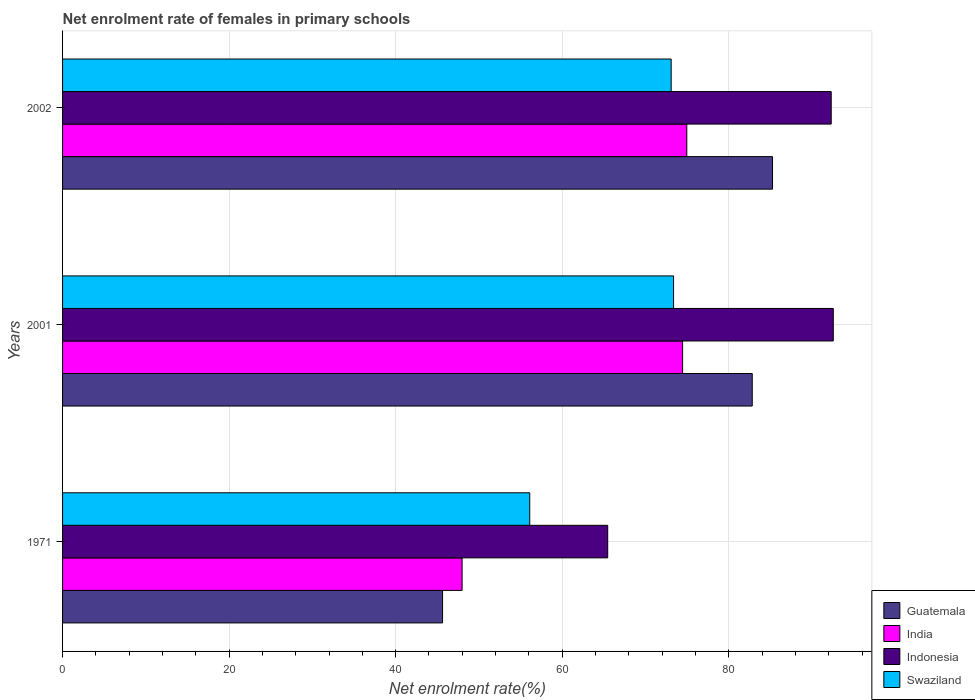How many groups of bars are there?
Make the answer very short. 3. How many bars are there on the 3rd tick from the top?
Ensure brevity in your answer.  4. What is the net enrolment rate of females in primary schools in Guatemala in 2001?
Your answer should be very brief. 82.82. Across all years, what is the maximum net enrolment rate of females in primary schools in Guatemala?
Keep it short and to the point. 85.26. Across all years, what is the minimum net enrolment rate of females in primary schools in Indonesia?
Your response must be concise. 65.46. In which year was the net enrolment rate of females in primary schools in Indonesia maximum?
Provide a short and direct response. 2001. In which year was the net enrolment rate of females in primary schools in Swaziland minimum?
Your answer should be compact. 1971. What is the total net enrolment rate of females in primary schools in Indonesia in the graph?
Give a very brief answer. 250.32. What is the difference between the net enrolment rate of females in primary schools in Indonesia in 1971 and that in 2002?
Make the answer very short. -26.84. What is the difference between the net enrolment rate of females in primary schools in Indonesia in 1971 and the net enrolment rate of females in primary schools in India in 2001?
Your answer should be very brief. -8.99. What is the average net enrolment rate of females in primary schools in India per year?
Make the answer very short. 65.8. In the year 2002, what is the difference between the net enrolment rate of females in primary schools in Guatemala and net enrolment rate of females in primary schools in Swaziland?
Provide a succinct answer. 12.17. In how many years, is the net enrolment rate of females in primary schools in Swaziland greater than 12 %?
Give a very brief answer. 3. What is the ratio of the net enrolment rate of females in primary schools in Indonesia in 2001 to that in 2002?
Keep it short and to the point. 1. Is the net enrolment rate of females in primary schools in Swaziland in 1971 less than that in 2001?
Keep it short and to the point. Yes. Is the difference between the net enrolment rate of females in primary schools in Guatemala in 1971 and 2001 greater than the difference between the net enrolment rate of females in primary schools in Swaziland in 1971 and 2001?
Your answer should be very brief. No. What is the difference between the highest and the second highest net enrolment rate of females in primary schools in Swaziland?
Give a very brief answer. 0.29. What is the difference between the highest and the lowest net enrolment rate of females in primary schools in Swaziland?
Make the answer very short. 17.27. In how many years, is the net enrolment rate of females in primary schools in Swaziland greater than the average net enrolment rate of females in primary schools in Swaziland taken over all years?
Provide a succinct answer. 2. Is the sum of the net enrolment rate of females in primary schools in Indonesia in 1971 and 2002 greater than the maximum net enrolment rate of females in primary schools in Guatemala across all years?
Keep it short and to the point. Yes. Is it the case that in every year, the sum of the net enrolment rate of females in primary schools in Guatemala and net enrolment rate of females in primary schools in India is greater than the sum of net enrolment rate of females in primary schools in Swaziland and net enrolment rate of females in primary schools in Indonesia?
Keep it short and to the point. No. What does the 4th bar from the bottom in 1971 represents?
Keep it short and to the point. Swaziland. How many bars are there?
Offer a terse response. 12. How many years are there in the graph?
Your answer should be compact. 3. Are the values on the major ticks of X-axis written in scientific E-notation?
Give a very brief answer. No. Where does the legend appear in the graph?
Give a very brief answer. Bottom right. How many legend labels are there?
Ensure brevity in your answer.  4. What is the title of the graph?
Your answer should be compact. Net enrolment rate of females in primary schools. Does "Australia" appear as one of the legend labels in the graph?
Offer a very short reply. No. What is the label or title of the X-axis?
Provide a succinct answer. Net enrolment rate(%). What is the Net enrolment rate(%) of Guatemala in 1971?
Keep it short and to the point. 45.63. What is the Net enrolment rate(%) in India in 1971?
Offer a terse response. 47.98. What is the Net enrolment rate(%) in Indonesia in 1971?
Your response must be concise. 65.46. What is the Net enrolment rate(%) in Swaziland in 1971?
Provide a succinct answer. 56.1. What is the Net enrolment rate(%) of Guatemala in 2001?
Make the answer very short. 82.82. What is the Net enrolment rate(%) of India in 2001?
Ensure brevity in your answer.  74.46. What is the Net enrolment rate(%) of Indonesia in 2001?
Offer a very short reply. 92.55. What is the Net enrolment rate(%) of Swaziland in 2001?
Your answer should be very brief. 73.37. What is the Net enrolment rate(%) in Guatemala in 2002?
Your answer should be very brief. 85.26. What is the Net enrolment rate(%) of India in 2002?
Provide a short and direct response. 74.96. What is the Net enrolment rate(%) in Indonesia in 2002?
Ensure brevity in your answer.  92.3. What is the Net enrolment rate(%) of Swaziland in 2002?
Your answer should be compact. 73.08. Across all years, what is the maximum Net enrolment rate(%) of Guatemala?
Keep it short and to the point. 85.26. Across all years, what is the maximum Net enrolment rate(%) of India?
Provide a succinct answer. 74.96. Across all years, what is the maximum Net enrolment rate(%) in Indonesia?
Give a very brief answer. 92.55. Across all years, what is the maximum Net enrolment rate(%) in Swaziland?
Ensure brevity in your answer.  73.37. Across all years, what is the minimum Net enrolment rate(%) in Guatemala?
Your answer should be compact. 45.63. Across all years, what is the minimum Net enrolment rate(%) in India?
Your answer should be compact. 47.98. Across all years, what is the minimum Net enrolment rate(%) of Indonesia?
Offer a very short reply. 65.46. Across all years, what is the minimum Net enrolment rate(%) of Swaziland?
Offer a very short reply. 56.1. What is the total Net enrolment rate(%) in Guatemala in the graph?
Give a very brief answer. 213.71. What is the total Net enrolment rate(%) of India in the graph?
Make the answer very short. 197.4. What is the total Net enrolment rate(%) in Indonesia in the graph?
Your answer should be compact. 250.32. What is the total Net enrolment rate(%) of Swaziland in the graph?
Provide a short and direct response. 202.56. What is the difference between the Net enrolment rate(%) of Guatemala in 1971 and that in 2001?
Your answer should be very brief. -37.19. What is the difference between the Net enrolment rate(%) of India in 1971 and that in 2001?
Ensure brevity in your answer.  -26.48. What is the difference between the Net enrolment rate(%) in Indonesia in 1971 and that in 2001?
Offer a terse response. -27.09. What is the difference between the Net enrolment rate(%) of Swaziland in 1971 and that in 2001?
Provide a succinct answer. -17.27. What is the difference between the Net enrolment rate(%) of Guatemala in 1971 and that in 2002?
Make the answer very short. -39.62. What is the difference between the Net enrolment rate(%) of India in 1971 and that in 2002?
Provide a succinct answer. -26.98. What is the difference between the Net enrolment rate(%) of Indonesia in 1971 and that in 2002?
Make the answer very short. -26.84. What is the difference between the Net enrolment rate(%) of Swaziland in 1971 and that in 2002?
Make the answer very short. -16.98. What is the difference between the Net enrolment rate(%) in Guatemala in 2001 and that in 2002?
Offer a very short reply. -2.43. What is the difference between the Net enrolment rate(%) in India in 2001 and that in 2002?
Your answer should be compact. -0.5. What is the difference between the Net enrolment rate(%) in Indonesia in 2001 and that in 2002?
Your answer should be compact. 0.25. What is the difference between the Net enrolment rate(%) of Swaziland in 2001 and that in 2002?
Offer a very short reply. 0.29. What is the difference between the Net enrolment rate(%) in Guatemala in 1971 and the Net enrolment rate(%) in India in 2001?
Offer a very short reply. -28.83. What is the difference between the Net enrolment rate(%) in Guatemala in 1971 and the Net enrolment rate(%) in Indonesia in 2001?
Ensure brevity in your answer.  -46.92. What is the difference between the Net enrolment rate(%) in Guatemala in 1971 and the Net enrolment rate(%) in Swaziland in 2001?
Keep it short and to the point. -27.74. What is the difference between the Net enrolment rate(%) in India in 1971 and the Net enrolment rate(%) in Indonesia in 2001?
Provide a short and direct response. -44.58. What is the difference between the Net enrolment rate(%) in India in 1971 and the Net enrolment rate(%) in Swaziland in 2001?
Make the answer very short. -25.4. What is the difference between the Net enrolment rate(%) of Indonesia in 1971 and the Net enrolment rate(%) of Swaziland in 2001?
Your answer should be very brief. -7.91. What is the difference between the Net enrolment rate(%) in Guatemala in 1971 and the Net enrolment rate(%) in India in 2002?
Keep it short and to the point. -29.33. What is the difference between the Net enrolment rate(%) in Guatemala in 1971 and the Net enrolment rate(%) in Indonesia in 2002?
Provide a short and direct response. -46.67. What is the difference between the Net enrolment rate(%) in Guatemala in 1971 and the Net enrolment rate(%) in Swaziland in 2002?
Provide a short and direct response. -27.45. What is the difference between the Net enrolment rate(%) in India in 1971 and the Net enrolment rate(%) in Indonesia in 2002?
Your response must be concise. -44.32. What is the difference between the Net enrolment rate(%) in India in 1971 and the Net enrolment rate(%) in Swaziland in 2002?
Your answer should be very brief. -25.11. What is the difference between the Net enrolment rate(%) of Indonesia in 1971 and the Net enrolment rate(%) of Swaziland in 2002?
Ensure brevity in your answer.  -7.62. What is the difference between the Net enrolment rate(%) of Guatemala in 2001 and the Net enrolment rate(%) of India in 2002?
Your response must be concise. 7.86. What is the difference between the Net enrolment rate(%) of Guatemala in 2001 and the Net enrolment rate(%) of Indonesia in 2002?
Offer a very short reply. -9.48. What is the difference between the Net enrolment rate(%) in Guatemala in 2001 and the Net enrolment rate(%) in Swaziland in 2002?
Give a very brief answer. 9.74. What is the difference between the Net enrolment rate(%) in India in 2001 and the Net enrolment rate(%) in Indonesia in 2002?
Offer a very short reply. -17.84. What is the difference between the Net enrolment rate(%) in India in 2001 and the Net enrolment rate(%) in Swaziland in 2002?
Your answer should be very brief. 1.37. What is the difference between the Net enrolment rate(%) in Indonesia in 2001 and the Net enrolment rate(%) in Swaziland in 2002?
Offer a terse response. 19.47. What is the average Net enrolment rate(%) of Guatemala per year?
Keep it short and to the point. 71.24. What is the average Net enrolment rate(%) of India per year?
Provide a succinct answer. 65.8. What is the average Net enrolment rate(%) in Indonesia per year?
Provide a succinct answer. 83.44. What is the average Net enrolment rate(%) of Swaziland per year?
Your answer should be very brief. 67.52. In the year 1971, what is the difference between the Net enrolment rate(%) in Guatemala and Net enrolment rate(%) in India?
Give a very brief answer. -2.35. In the year 1971, what is the difference between the Net enrolment rate(%) in Guatemala and Net enrolment rate(%) in Indonesia?
Your answer should be compact. -19.83. In the year 1971, what is the difference between the Net enrolment rate(%) of Guatemala and Net enrolment rate(%) of Swaziland?
Make the answer very short. -10.47. In the year 1971, what is the difference between the Net enrolment rate(%) in India and Net enrolment rate(%) in Indonesia?
Offer a terse response. -17.49. In the year 1971, what is the difference between the Net enrolment rate(%) of India and Net enrolment rate(%) of Swaziland?
Keep it short and to the point. -8.12. In the year 1971, what is the difference between the Net enrolment rate(%) in Indonesia and Net enrolment rate(%) in Swaziland?
Give a very brief answer. 9.36. In the year 2001, what is the difference between the Net enrolment rate(%) in Guatemala and Net enrolment rate(%) in India?
Ensure brevity in your answer.  8.36. In the year 2001, what is the difference between the Net enrolment rate(%) of Guatemala and Net enrolment rate(%) of Indonesia?
Provide a succinct answer. -9.73. In the year 2001, what is the difference between the Net enrolment rate(%) in Guatemala and Net enrolment rate(%) in Swaziland?
Your answer should be very brief. 9.45. In the year 2001, what is the difference between the Net enrolment rate(%) in India and Net enrolment rate(%) in Indonesia?
Offer a terse response. -18.1. In the year 2001, what is the difference between the Net enrolment rate(%) of India and Net enrolment rate(%) of Swaziland?
Make the answer very short. 1.08. In the year 2001, what is the difference between the Net enrolment rate(%) in Indonesia and Net enrolment rate(%) in Swaziland?
Give a very brief answer. 19.18. In the year 2002, what is the difference between the Net enrolment rate(%) of Guatemala and Net enrolment rate(%) of India?
Your response must be concise. 10.29. In the year 2002, what is the difference between the Net enrolment rate(%) in Guatemala and Net enrolment rate(%) in Indonesia?
Your answer should be compact. -7.05. In the year 2002, what is the difference between the Net enrolment rate(%) in Guatemala and Net enrolment rate(%) in Swaziland?
Make the answer very short. 12.17. In the year 2002, what is the difference between the Net enrolment rate(%) in India and Net enrolment rate(%) in Indonesia?
Provide a short and direct response. -17.34. In the year 2002, what is the difference between the Net enrolment rate(%) in India and Net enrolment rate(%) in Swaziland?
Your answer should be compact. 1.88. In the year 2002, what is the difference between the Net enrolment rate(%) in Indonesia and Net enrolment rate(%) in Swaziland?
Ensure brevity in your answer.  19.22. What is the ratio of the Net enrolment rate(%) in Guatemala in 1971 to that in 2001?
Your answer should be compact. 0.55. What is the ratio of the Net enrolment rate(%) in India in 1971 to that in 2001?
Give a very brief answer. 0.64. What is the ratio of the Net enrolment rate(%) of Indonesia in 1971 to that in 2001?
Keep it short and to the point. 0.71. What is the ratio of the Net enrolment rate(%) of Swaziland in 1971 to that in 2001?
Your answer should be compact. 0.76. What is the ratio of the Net enrolment rate(%) of Guatemala in 1971 to that in 2002?
Provide a short and direct response. 0.54. What is the ratio of the Net enrolment rate(%) in India in 1971 to that in 2002?
Make the answer very short. 0.64. What is the ratio of the Net enrolment rate(%) in Indonesia in 1971 to that in 2002?
Keep it short and to the point. 0.71. What is the ratio of the Net enrolment rate(%) of Swaziland in 1971 to that in 2002?
Ensure brevity in your answer.  0.77. What is the ratio of the Net enrolment rate(%) of Guatemala in 2001 to that in 2002?
Your answer should be very brief. 0.97. What is the ratio of the Net enrolment rate(%) in Indonesia in 2001 to that in 2002?
Provide a succinct answer. 1. What is the difference between the highest and the second highest Net enrolment rate(%) in Guatemala?
Give a very brief answer. 2.43. What is the difference between the highest and the second highest Net enrolment rate(%) of India?
Your response must be concise. 0.5. What is the difference between the highest and the second highest Net enrolment rate(%) of Indonesia?
Offer a terse response. 0.25. What is the difference between the highest and the second highest Net enrolment rate(%) of Swaziland?
Your answer should be compact. 0.29. What is the difference between the highest and the lowest Net enrolment rate(%) of Guatemala?
Provide a succinct answer. 39.62. What is the difference between the highest and the lowest Net enrolment rate(%) of India?
Your answer should be compact. 26.98. What is the difference between the highest and the lowest Net enrolment rate(%) of Indonesia?
Offer a terse response. 27.09. What is the difference between the highest and the lowest Net enrolment rate(%) of Swaziland?
Provide a short and direct response. 17.27. 